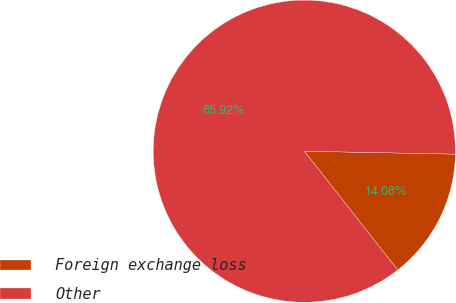Convert chart. <chart><loc_0><loc_0><loc_500><loc_500><pie_chart><fcel>Foreign exchange loss<fcel>Other<nl><fcel>14.08%<fcel>85.92%<nl></chart> 